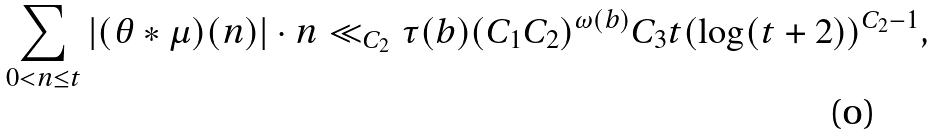Convert formula to latex. <formula><loc_0><loc_0><loc_500><loc_500>\sum _ { 0 < n \leq t } | ( \theta * \mu ) ( n ) | \cdot n \ll _ { C _ { 2 } } \tau ( b ) ( C _ { 1 } C _ { 2 } ) ^ { \omega ( b ) } C _ { 3 } t ( \log ( t + 2 ) ) ^ { C _ { 2 } - 1 } ,</formula> 